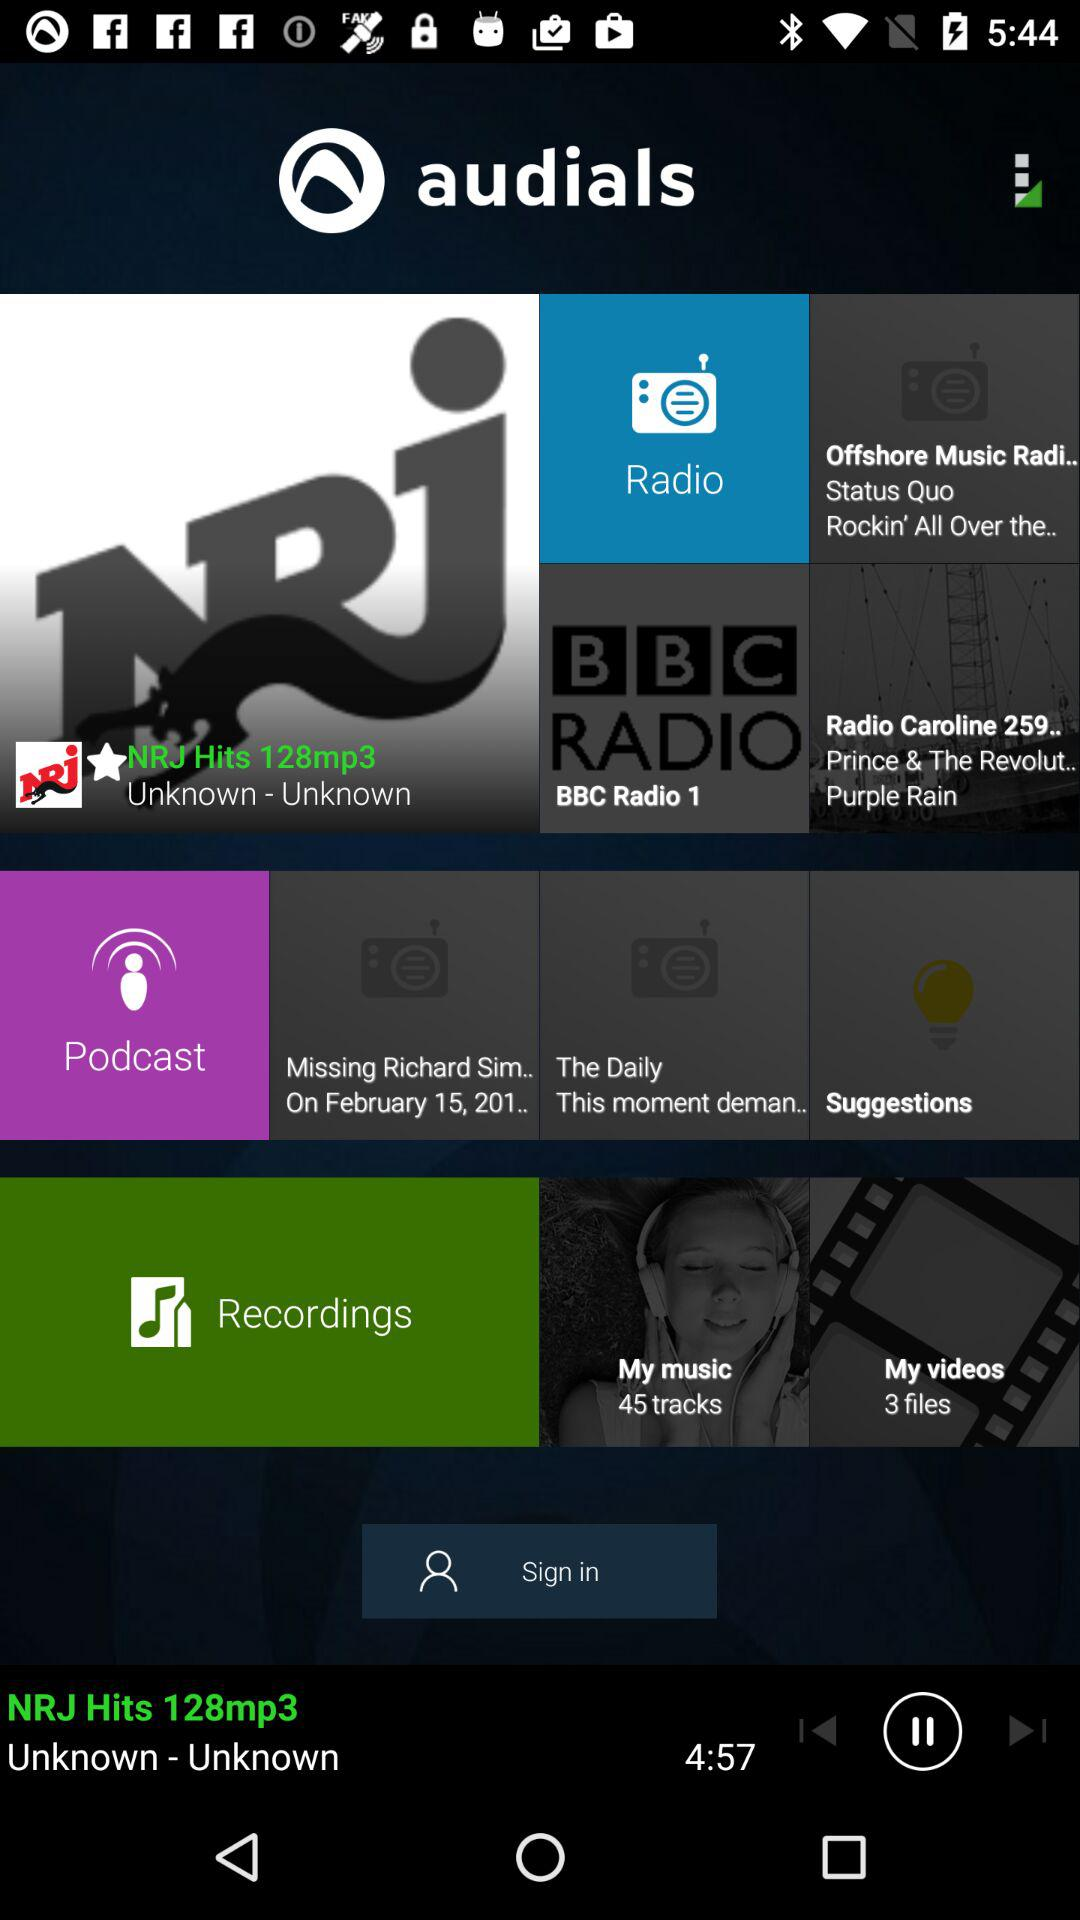On February 15, which podcast will be released? - Which podcast will be released on February 15? The podcast "Missing Richard Sim.." will be released on February 15. 